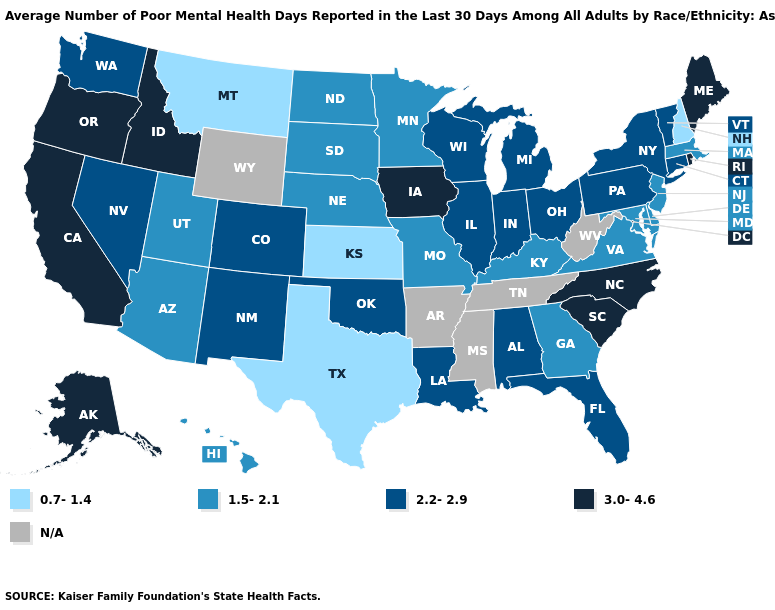Name the states that have a value in the range 0.7-1.4?
Be succinct. Kansas, Montana, New Hampshire, Texas. Which states hav the highest value in the MidWest?
Write a very short answer. Iowa. Which states have the lowest value in the USA?
Keep it brief. Kansas, Montana, New Hampshire, Texas. What is the value of Idaho?
Concise answer only. 3.0-4.6. Does the first symbol in the legend represent the smallest category?
Keep it brief. Yes. Name the states that have a value in the range 0.7-1.4?
Answer briefly. Kansas, Montana, New Hampshire, Texas. What is the value of West Virginia?
Short answer required. N/A. What is the lowest value in the MidWest?
Be succinct. 0.7-1.4. What is the value of Idaho?
Answer briefly. 3.0-4.6. Among the states that border Tennessee , does North Carolina have the highest value?
Answer briefly. Yes. Does the map have missing data?
Give a very brief answer. Yes. Name the states that have a value in the range 3.0-4.6?
Write a very short answer. Alaska, California, Idaho, Iowa, Maine, North Carolina, Oregon, Rhode Island, South Carolina. 